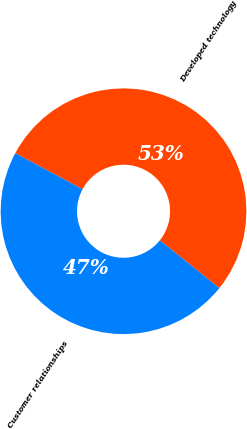<chart> <loc_0><loc_0><loc_500><loc_500><pie_chart><fcel>Developed technology<fcel>Customer relationships<nl><fcel>52.92%<fcel>47.08%<nl></chart> 